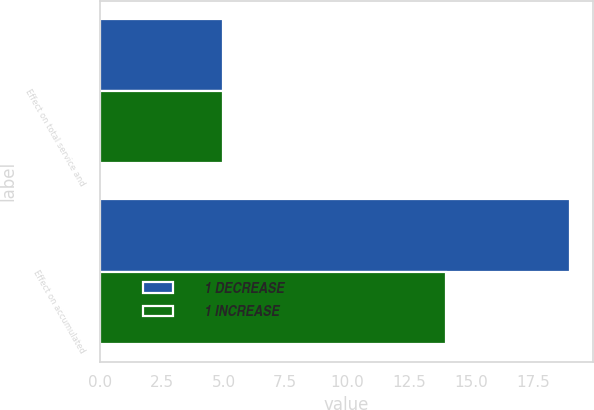Convert chart. <chart><loc_0><loc_0><loc_500><loc_500><stacked_bar_chart><ecel><fcel>Effect on total service and<fcel>Effect on accumulated<nl><fcel>1 DECREASE<fcel>5<fcel>19<nl><fcel>1 INCREASE<fcel>5<fcel>14<nl></chart> 